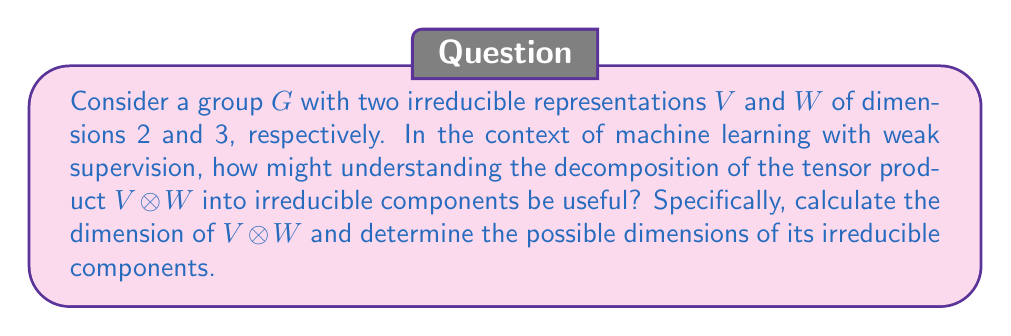Could you help me with this problem? Let's approach this step-by-step:

1) First, we need to calculate the dimension of $V \otimes W$:
   $\dim(V \otimes W) = \dim(V) \cdot \dim(W) = 2 \cdot 3 = 6$

2) Now, we need to consider the possible ways to decompose a 6-dimensional representation into irreducible components. The possible combinations are:
   a) 6 (one irreducible 6-dimensional representation)
   b) 5 + 1
   c) 4 + 2
   d) 3 + 3
   e) 3 + 2 + 1
   f) 2 + 2 + 2
   g) 2 + 2 + 1 + 1
   h) 2 + 1 + 1 + 1 + 1
   i) 1 + 1 + 1 + 1 + 1 + 1

3) In the context of machine learning with weak supervision, understanding this decomposition can be useful in several ways:

   a) Feature representation: Each irreducible component can be thought of as a fundamental feature. The decomposition shows how complex features (tensor product) can be broken down into simpler, independent features.

   b) Dimensionality reduction: If the tensor product decomposes into fewer high-dimensional irreducible components (e.g., 6 or 5+1), it suggests that the original features (V and W) have strong interactions. This could inform feature selection or engineering processes in ML pipelines.

   c) Model complexity: The number and dimensions of irreducible components can indicate the complexity of the relationship between features. This could guide decisions on model architecture or regularization in weakly supervised learning scenarios.

   d) Transfer learning: Understanding how representations decompose can inform strategies for transferring knowledge between tasks, which is particularly relevant in weak supervision settings where labeled data might be scarce.

4) The actual decomposition would depend on the specific group G and its action on V and W, which is not provided in this question. However, the possible dimensions of irreducible components are those listed in step 2.
Answer: Dimension of $V \otimes W$: 6. Possible dimensions of irreducible components: 6, 5, 4, 3, 2, 1 in various combinations summing to 6. 